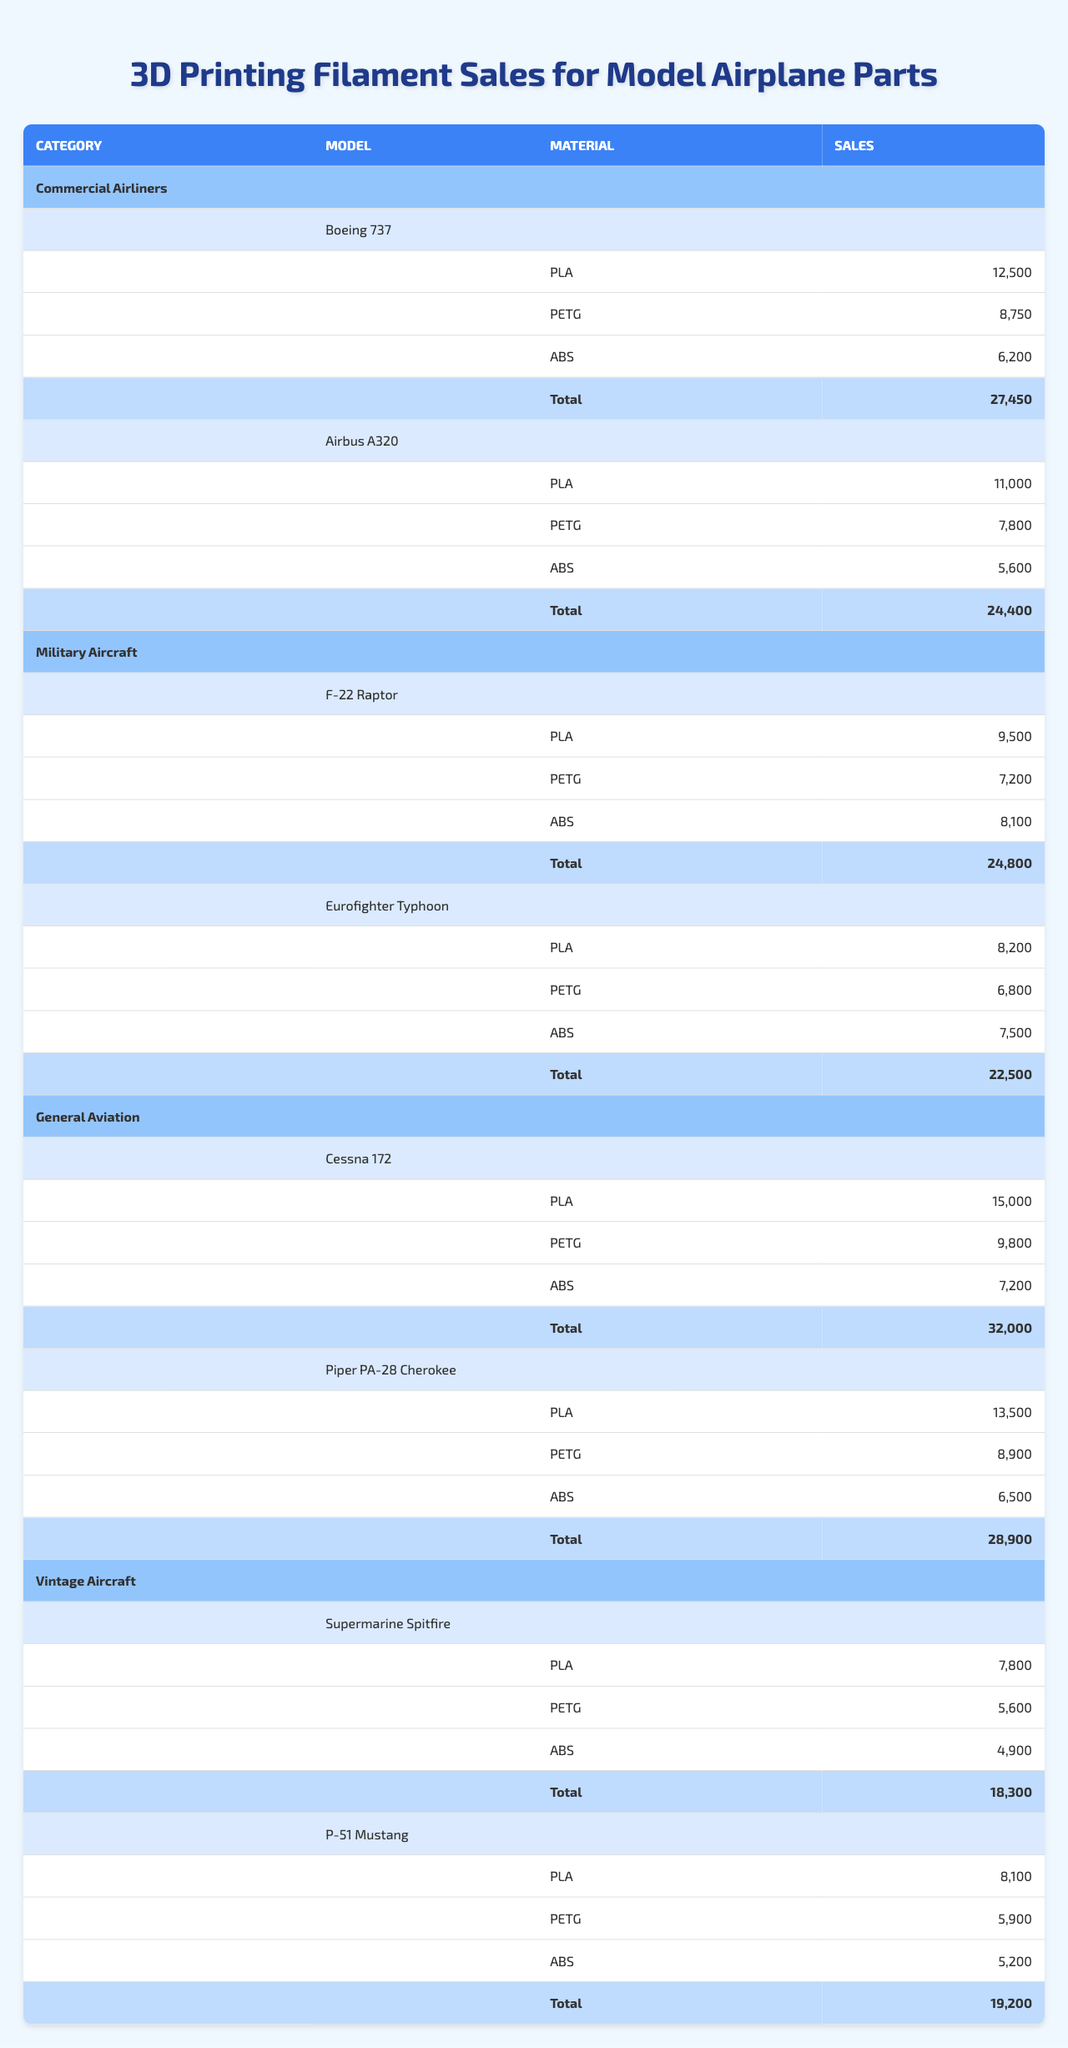What is the total filament sales for the Boeing 737 model? The Boeing 737 has filament sales distributed across PLA, PETG, and ABS. Summing these sales gives 12500 + 8750 + 6200 = 30450.
Answer: 30450 Which model sold the least amount of ABS filament? The ABS sales for each model are: Boeing 737 (6200), Airbus A320 (5600), F-22 Raptor (8100), Eurofighter Typhoon (7500), Cessna 172 (7200), Piper PA-28 Cherokee (6500), Supermarine Spitfire (4900), and P-51 Mustang (5200). The least is for the Supermarine Spitfire at 4900.
Answer: Supermarine Spitfire What is the total sales for all models of commercial airliners? The total sales for the Boeing 737 is 30450 (from earlier calculation) and for the Airbus A320 is 11000 + 7800 + 5600 = 24400. Thus, total sales for commercial airliners is 30450 + 24400 = 54850.
Answer: 54850 How much more PLA filament was sold for the Cessna 172 than for the Eurofighter Typhoon? The PLA sales for Cessna 172 is 15000 and for Eurofighter Typhoon is 8200. The difference is 15000 - 8200 = 6800.
Answer: 6800 Is it true that the total sales of the Supermarine Spitfire is greater than the total sales of the Cessna 172? The total sales for Supermarine Spitfire is 7800 + 5600 + 4900 = 18800. For Cessna 172, it is 15000 + 9800 + 7200 = 32000. Since 18800 is less than 32000, the statement is false.
Answer: No What is the average sales of PETG filament across all airplane models? The PETG sales are: Boeing 737 (8750), Airbus A320 (7800), F-22 Raptor (7200), Eurofighter Typhoon (6800), Cessna 172 (9800), Piper PA-28 Cherokee (8900), Supermarine Spitfire (5600), and P-51 Mustang (5900). Adding them gives 8750 + 7800 + 7200 + 6800 + 9800 + 8900 + 5600 + 5900 = 49650. There are 8 values, so the average is 49650/8 = 6206.25.
Answer: 6206.25 What is the combined total sales of ABS filament for all military aircraft models? For military aircraft: F-22 Raptor ABS sales is 8100, Eurofighter Typhoon ABS sales is 7500, thus total ABS sales is 8100 + 7500 = 15600.
Answer: 15600 Which category has the highest total filament sales? Calculating totals for each category: Commercial Airliners = 54850, Military Aircraft = 15600, General Aviation = 40400, Vintage Aircraft = 18800. The highest is Commercial Airliners with 54850.
Answer: Commercial Airliners If we compare the total sales of PLA from vintage aircraft to general aviation, which one has higher sales? Vintage aircraft PLA sales: Supermarine Spitfire (7800) + P-51 Mustang (8100) = 15900. General aviation PLA sales: Cessna 172 (15000) + Piper PA-28 Cherokee (13500) = 28500. General aviation has higher sales.
Answer: General Aviation 